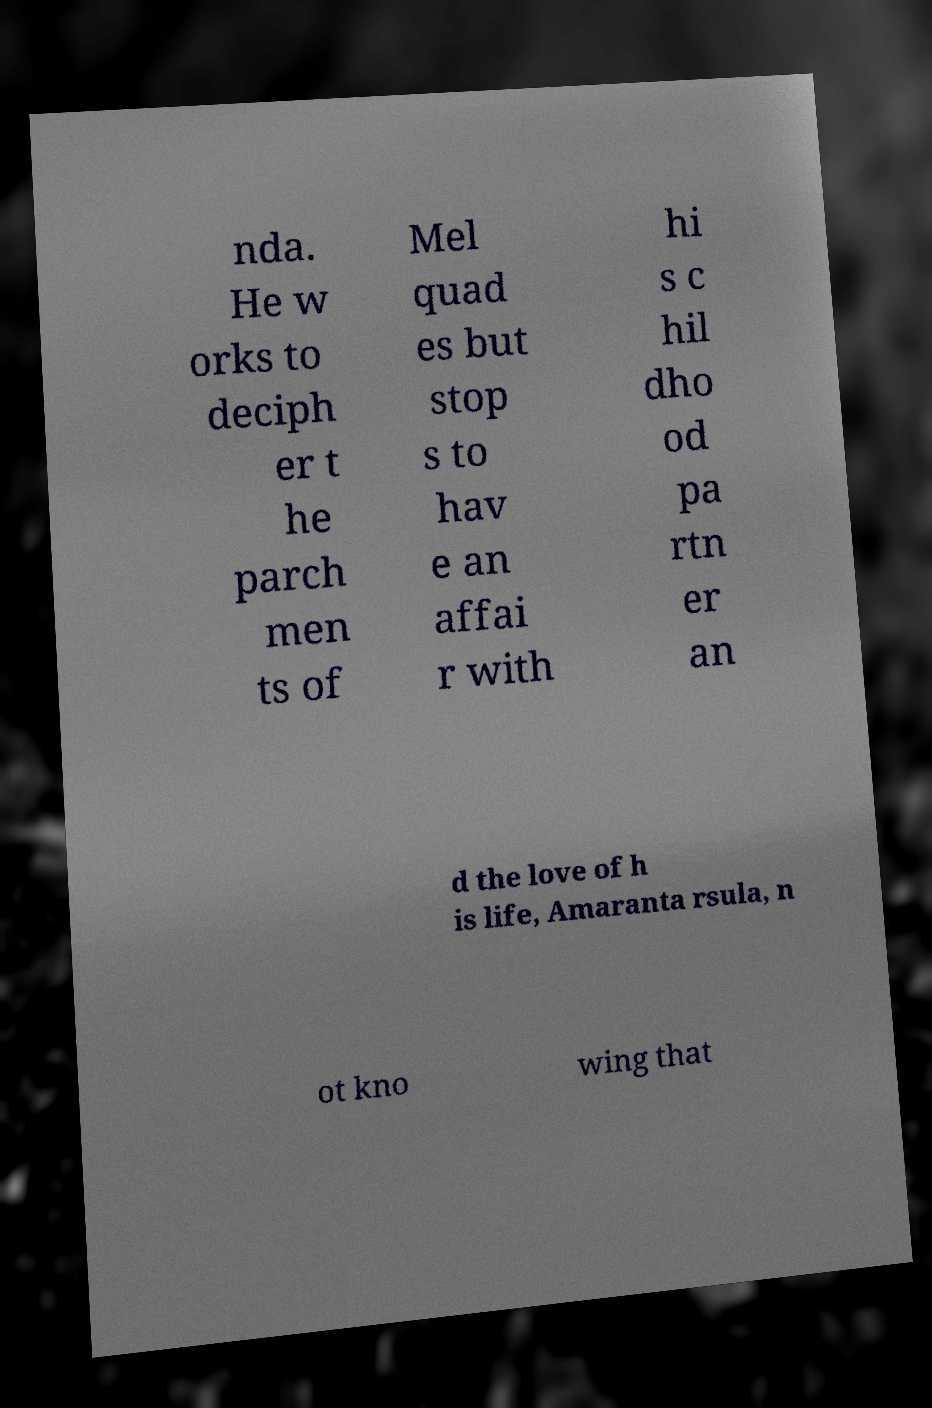Please read and relay the text visible in this image. What does it say? nda. He w orks to deciph er t he parch men ts of Mel quad es but stop s to hav e an affai r with hi s c hil dho od pa rtn er an d the love of h is life, Amaranta rsula, n ot kno wing that 